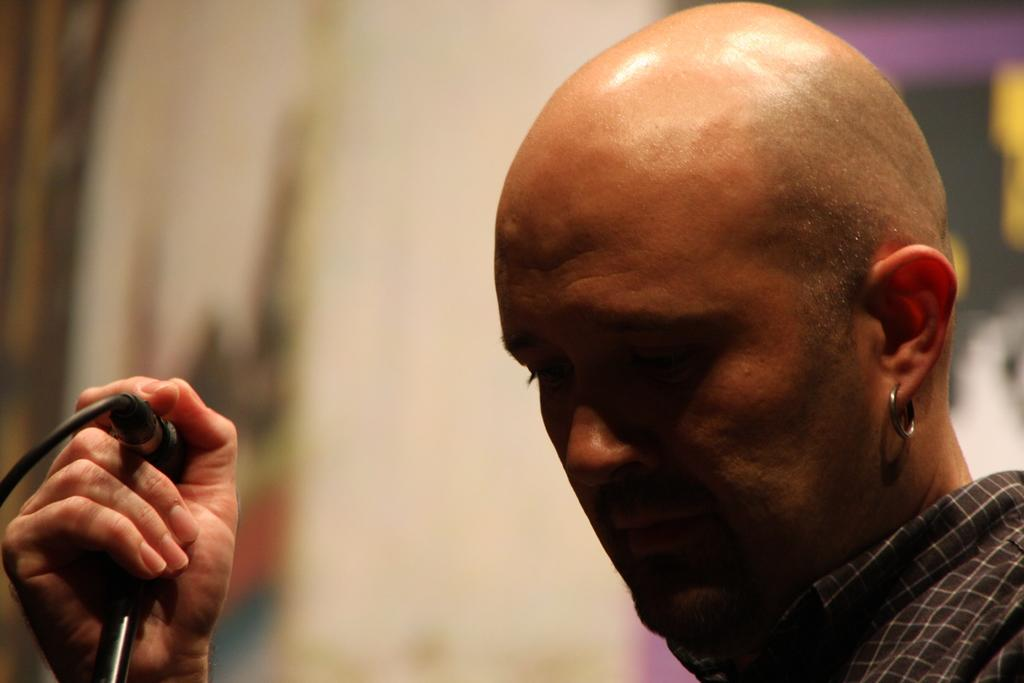What can be seen on the right side of the image? There is a person on the right side of the image. What is the person wearing? The person is wearing a shirt. What is the appearance of the person's head? The person has a bald head. What is the person holding in the image? The person is holding a microphone. How is the microphone attached in the image? The microphone is attached to a stand. What can be observed about the background of the image? The background of the image is blurred. What type of pain is the person experiencing in the image? There is no indication of pain in the image; the person appears to be holding a microphone. 